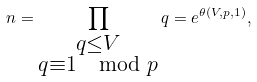Convert formula to latex. <formula><loc_0><loc_0><loc_500><loc_500>n = \prod _ { \substack { q \leq V \\ q \equiv 1 \mod p } } q = e ^ { \theta ( V , p , 1 ) } ,</formula> 